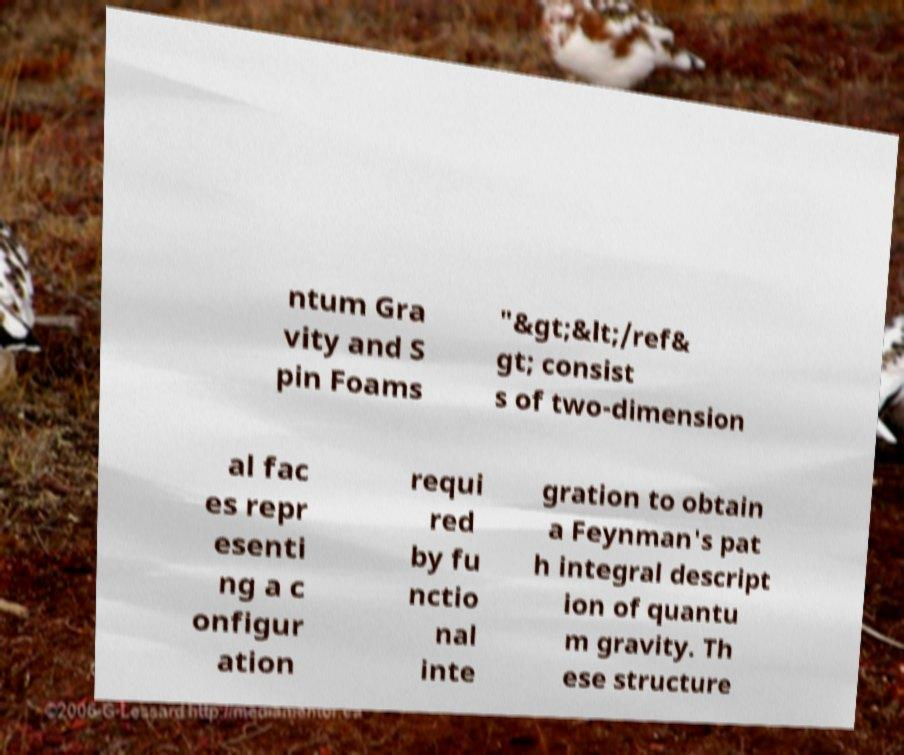Please identify and transcribe the text found in this image. ntum Gra vity and S pin Foams "&gt;&lt;/ref& gt; consist s of two-dimension al fac es repr esenti ng a c onfigur ation requi red by fu nctio nal inte gration to obtain a Feynman's pat h integral descript ion of quantu m gravity. Th ese structure 